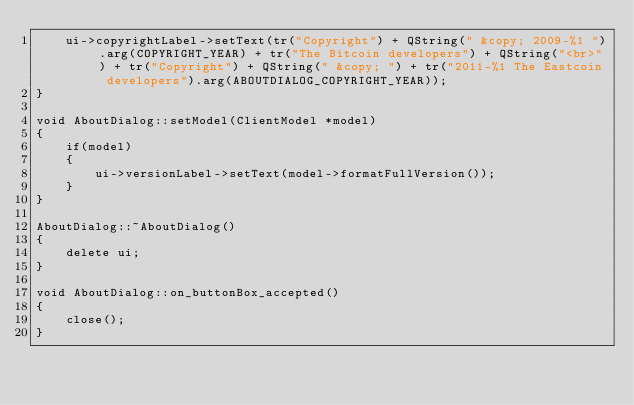Convert code to text. <code><loc_0><loc_0><loc_500><loc_500><_C++_>    ui->copyrightLabel->setText(tr("Copyright") + QString(" &copy; 2009-%1 ").arg(COPYRIGHT_YEAR) + tr("The Bitcoin developers") + QString("<br>") + tr("Copyright") + QString(" &copy; ") + tr("2011-%1 The Eastcoin developers").arg(ABOUTDIALOG_COPYRIGHT_YEAR));
}

void AboutDialog::setModel(ClientModel *model)
{
    if(model)
    {
        ui->versionLabel->setText(model->formatFullVersion());
    }
}

AboutDialog::~AboutDialog()
{
    delete ui;
}

void AboutDialog::on_buttonBox_accepted()
{
    close();
}
</code> 